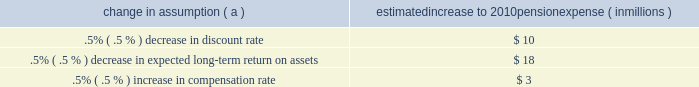Investment policy , which is described more fully in note 15 employee benefit plans in the notes to consolidated financial statements in item 8 of this report .
We calculate the expense associated with the pension plan and the assumptions and methods that we use include a policy of reflecting trust assets at their fair market value .
On an annual basis , we review the actuarial assumptions related to the pension plan , including the discount rate , the rate of compensation increase and the expected return on plan assets .
The discount rate and compensation increase assumptions do not significantly affect pension expense .
However , the expected long-term return on assets assumption does significantly affect pension expense .
Our expected long- term return on plan assets for determining net periodic pension expense has been 8.25% ( 8.25 % ) for the past three years .
The expected return on plan assets is a long-term assumption established by considering historical and anticipated returns of the asset classes invested in by the pension plan and the allocation strategy currently in place among those classes .
While this analysis gives appropriate consideration to recent asset performance and historical returns , the assumption represents a long-term prospective return .
We review this assumption at each measurement date and adjust it if warranted .
For purposes of setting and reviewing this assumption , 201clong- term 201d refers to the period over which the plan 2019s projected benefit obligation will be disbursed .
While year-to-year annual returns can vary significantly ( rates of return for the reporting years of 2009 , 2008 , and 2007 were +20.61% ( +20.61 % ) , -32.91% ( -32.91 % ) , and +7.57% ( +7.57 % ) , respectively ) , the assumption represents our estimate of long-term average prospective returns .
Our selection process references certain historical data and the current environment , but primarily utilizes qualitative judgment regarding future return expectations .
Recent annual returns may differ but , recognizing the volatility and unpredictability of investment returns , we generally do not change the assumption unless we modify our investment strategy or identify events that would alter our expectations of future returns .
To evaluate the continued reasonableness of our assumption , we examine a variety of viewpoints and data .
Various studies have shown that portfolios comprised primarily of us equity securities have returned approximately 10% ( 10 % ) over long periods of time , while us debt securities have returned approximately 6% ( 6 % ) annually over long periods .
Application of these historical returns to the plan 2019s allocation of equities and bonds produces a result between 8% ( 8 % ) and 8.5% ( 8.5 % ) and is one point of reference , among many other factors , that is taken into consideration .
We also examine the plan 2019s actual historical returns over various periods .
Recent experience is considered in our evaluation with appropriate consideration that , especially for short time periods , recent returns are not reliable indicators of future returns , and in many cases low returns in recent time periods are followed by higher returns in future periods ( and vice versa ) .
Acknowledging the potentially wide range for this assumption , we also annually examine the assumption used by other companies with similar pension investment strategies , so that we can ascertain whether our determinations markedly differ from other observers .
In all cases , however , this data simply informs our process , which places the greatest emphasis on our qualitative judgment of future investment returns , given the conditions existing at each annual measurement date .
The expected long-term return on plan assets for determining net periodic pension cost for 2009 was 8.25% ( 8.25 % ) , unchanged from 2008 .
During 2010 , we intend to decrease the midpoint of the plan 2019s target allocation range for equities by approximately five percentage points .
As a result of this change and taking into account all other factors described above , pnc will change the expected long-term return on plan assets to 8.00% ( 8.00 % ) for determining net periodic pension cost for 2010 .
Under current accounting rules , the difference between expected long-term returns and actual returns is accumulated and amortized to pension expense over future periods .
Each one percentage point difference in actual return compared with our expected return causes expense in subsequent years to change by up to $ 8 million as the impact is amortized into results of operations .
The table below reflects the estimated effects on pension expense of certain changes in annual assumptions , using 2010 estimated expense as a baseline .
Change in assumption ( a ) estimated increase to 2010 pension expense ( in millions ) .
( a ) the impact is the effect of changing the specified assumption while holding all other assumptions constant .
We currently estimate a pretax pension expense of $ 41 million in 2010 compared with pretax expense of $ 117 million in 2009 .
This year-over-year reduction was primarily due to the amortization impact of the favorable 2009 investment returns as compared with the expected long-term return assumption .
Our pension plan contribution requirements are not particularly sensitive to actuarial assumptions .
Investment performance has the most impact on contribution requirements and will drive the amount of permitted contributions in future years .
Also , current law , including the provisions of the pension protection act of 2006 , sets limits as to both minimum and maximum contributions to the plan .
We expect that the minimum required contributions under the law will be zero for 2010 .
We maintain other defined benefit plans that have a less significant effect on financial results , including various .
The decrease in pretax pension expenses was what percentage of a decrease? 
Computations: ((117 - 41) / 117)
Answer: 0.64957. 